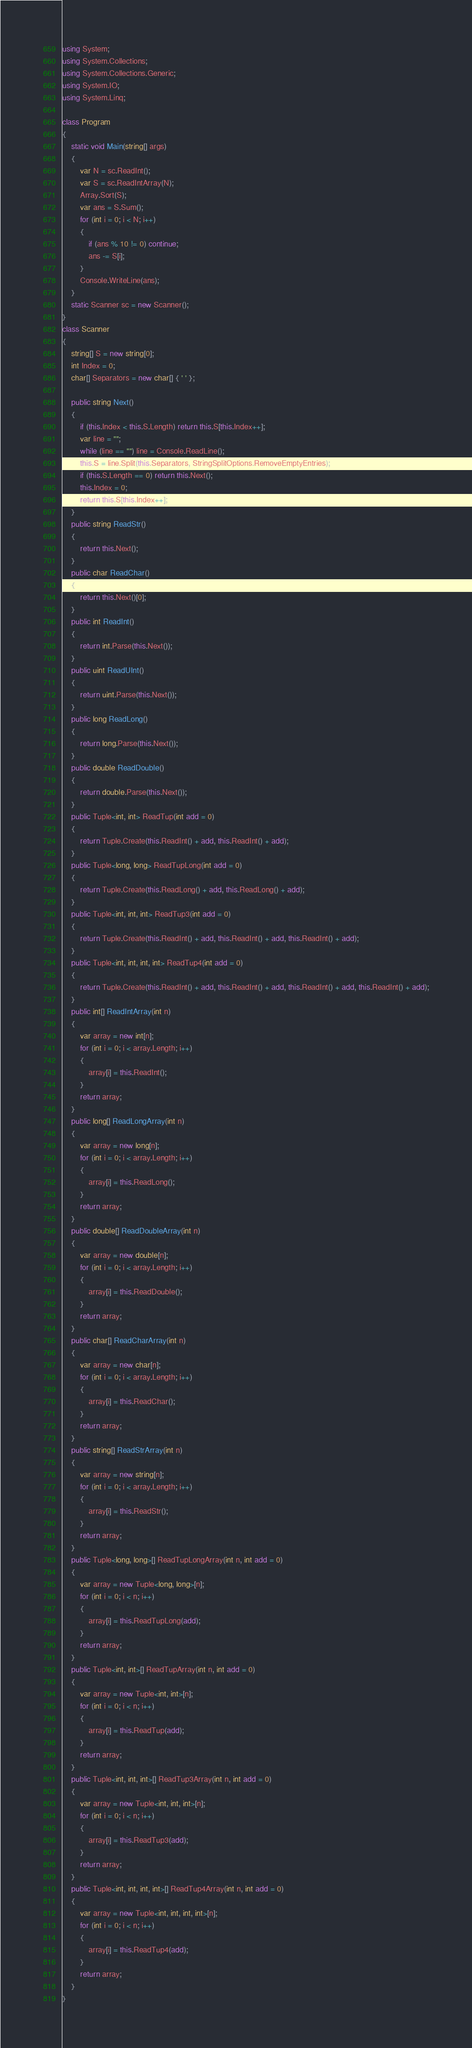Convert code to text. <code><loc_0><loc_0><loc_500><loc_500><_C#_>using System;
using System.Collections;
using System.Collections.Generic;
using System.IO;
using System.Linq;

class Program
{
    static void Main(string[] args)
    {
        var N = sc.ReadInt();
        var S = sc.ReadIntArray(N);
        Array.Sort(S);
        var ans = S.Sum();
        for (int i = 0; i < N; i++)
        {
            if (ans % 10 != 0) continue;
            ans -= S[i];
        }
        Console.WriteLine(ans);
    }
    static Scanner sc = new Scanner();
}
class Scanner
{
    string[] S = new string[0];
    int Index = 0;
    char[] Separators = new char[] { ' ' };

    public string Next()
    {
        if (this.Index < this.S.Length) return this.S[this.Index++];
        var line = "";
        while (line == "") line = Console.ReadLine();
        this.S = line.Split(this.Separators, StringSplitOptions.RemoveEmptyEntries);
        if (this.S.Length == 0) return this.Next();
        this.Index = 0;
        return this.S[this.Index++];
    }
    public string ReadStr()
    {
        return this.Next();
    }
    public char ReadChar()
    {
        return this.Next()[0];
    }
    public int ReadInt()
    {
        return int.Parse(this.Next());
    }
    public uint ReadUInt()
    {
        return uint.Parse(this.Next());
    }
    public long ReadLong()
    {
        return long.Parse(this.Next());
    }
    public double ReadDouble()
    {
        return double.Parse(this.Next());
    }
    public Tuple<int, int> ReadTup(int add = 0)
    {
        return Tuple.Create(this.ReadInt() + add, this.ReadInt() + add);
    }
    public Tuple<long, long> ReadTupLong(int add = 0)
    {
        return Tuple.Create(this.ReadLong() + add, this.ReadLong() + add);
    }
    public Tuple<int, int, int> ReadTup3(int add = 0)
    {
        return Tuple.Create(this.ReadInt() + add, this.ReadInt() + add, this.ReadInt() + add);
    }
    public Tuple<int, int, int, int> ReadTup4(int add = 0)
    {
        return Tuple.Create(this.ReadInt() + add, this.ReadInt() + add, this.ReadInt() + add, this.ReadInt() + add);
    }
    public int[] ReadIntArray(int n)
    {
        var array = new int[n];
        for (int i = 0; i < array.Length; i++)
        {
            array[i] = this.ReadInt();
        }
        return array;
    }
    public long[] ReadLongArray(int n)
    {
        var array = new long[n];
        for (int i = 0; i < array.Length; i++)
        {
            array[i] = this.ReadLong();
        }
        return array;
    }
    public double[] ReadDoubleArray(int n)
    {
        var array = new double[n];
        for (int i = 0; i < array.Length; i++)
        {
            array[i] = this.ReadDouble();
        }
        return array;
    }
    public char[] ReadCharArray(int n)
    {
        var array = new char[n];
        for (int i = 0; i < array.Length; i++)
        {
            array[i] = this.ReadChar();
        }
        return array;
    }
    public string[] ReadStrArray(int n)
    {
        var array = new string[n];
        for (int i = 0; i < array.Length; i++)
        {
            array[i] = this.ReadStr();
        }
        return array;
    }
    public Tuple<long, long>[] ReadTupLongArray(int n, int add = 0)
    {
        var array = new Tuple<long, long>[n];
        for (int i = 0; i < n; i++)
        {
            array[i] = this.ReadTupLong(add);
        }
        return array;
    }
    public Tuple<int, int>[] ReadTupArray(int n, int add = 0)
    {
        var array = new Tuple<int, int>[n];
        for (int i = 0; i < n; i++)
        {
            array[i] = this.ReadTup(add);
        }
        return array;
    }
    public Tuple<int, int, int>[] ReadTup3Array(int n, int add = 0)
    {
        var array = new Tuple<int, int, int>[n];
        for (int i = 0; i < n; i++)
        {
            array[i] = this.ReadTup3(add);
        }
        return array;
    }
    public Tuple<int, int, int, int>[] ReadTup4Array(int n, int add = 0)
    {
        var array = new Tuple<int, int, int, int>[n];
        for (int i = 0; i < n; i++)
        {
            array[i] = this.ReadTup4(add);
        }
        return array;
    }
}
</code> 